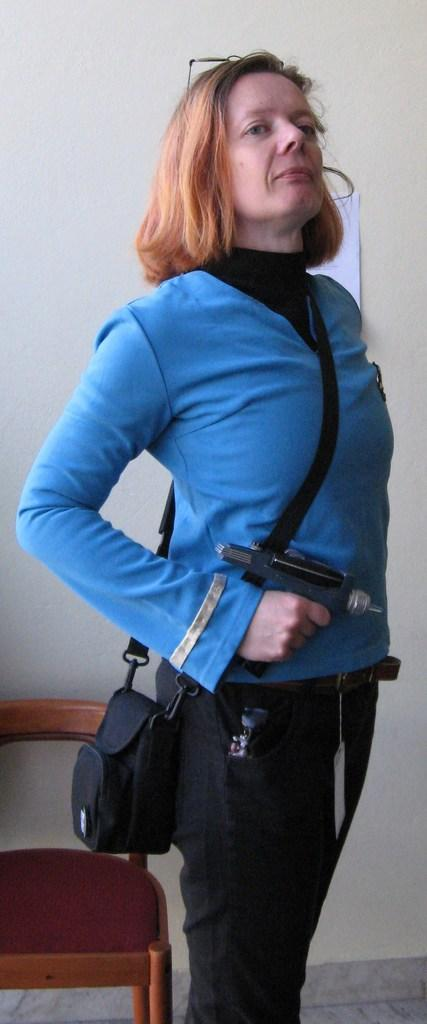Who is present in the image? There is a woman in the image. What is the woman holding in her hands? The woman is holding a gun in her hands. What is the woman carrying in the image? The woman is carrying a bag. What is the woman's posture in the image? The woman is standing. What can be seen in the background of the image? There is a wall and a chair in the background of the image. What type of stick is the woman using to stir the steam in the jar? There is no stick, steam, or jar present in the image. 